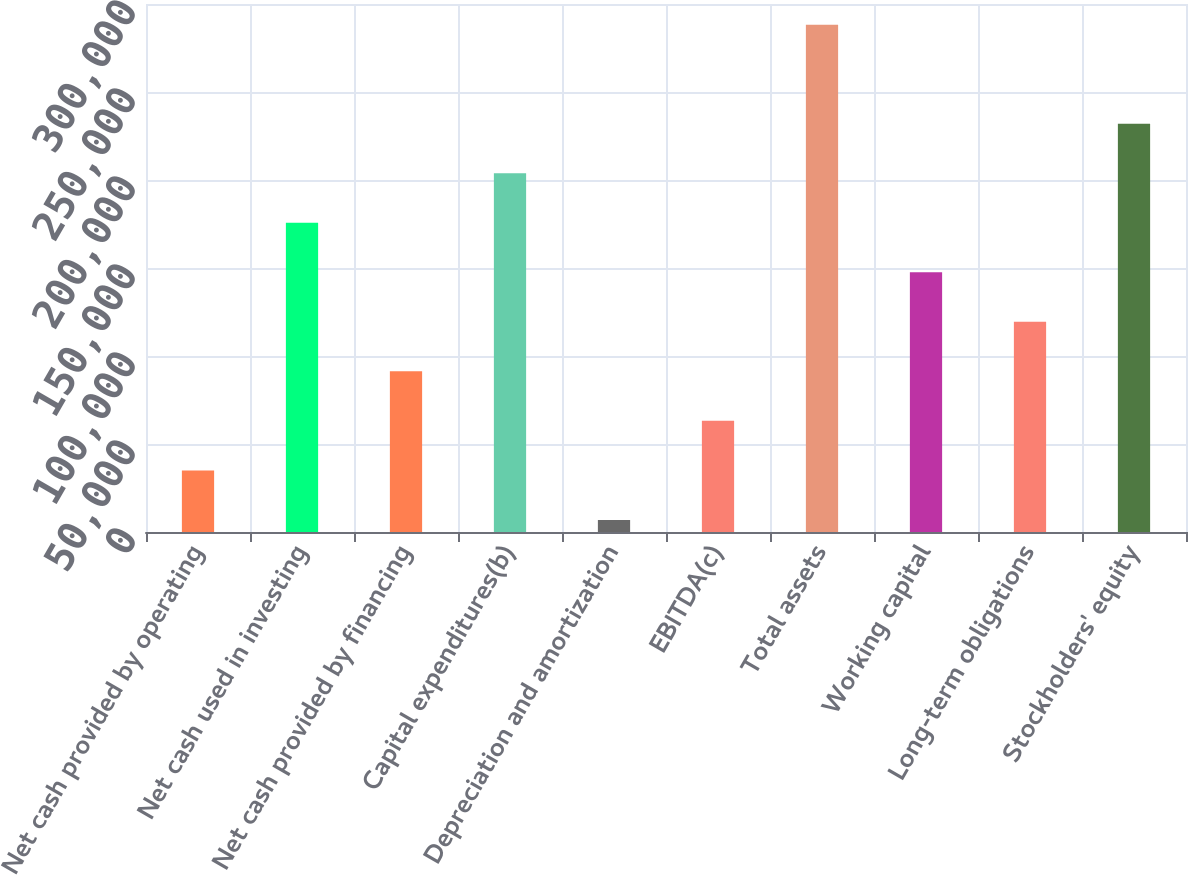<chart> <loc_0><loc_0><loc_500><loc_500><bar_chart><fcel>Net cash provided by operating<fcel>Net cash used in investing<fcel>Net cash provided by financing<fcel>Capital expenditures(b)<fcel>Depreciation and amortization<fcel>EBITDA(c)<fcel>Total assets<fcel>Working capital<fcel>Long-term obligations<fcel>Stockholders' equity<nl><fcel>35012.3<fcel>175714<fcel>91292.9<fcel>203854<fcel>6872<fcel>63152.6<fcel>288275<fcel>147574<fcel>119433<fcel>231994<nl></chart> 